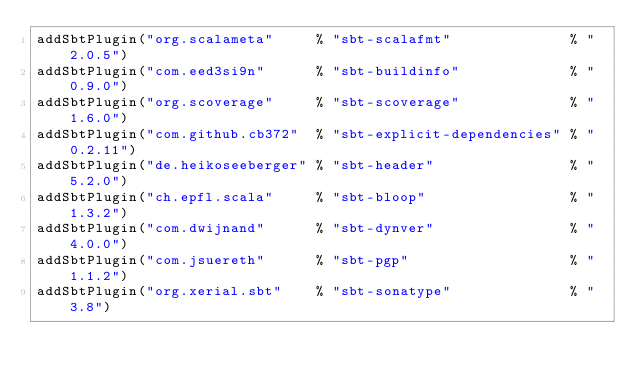Convert code to text. <code><loc_0><loc_0><loc_500><loc_500><_Scala_>addSbtPlugin("org.scalameta"     % "sbt-scalafmt"              % "2.0.5")
addSbtPlugin("com.eed3si9n"      % "sbt-buildinfo"             % "0.9.0")
addSbtPlugin("org.scoverage"     % "sbt-scoverage"             % "1.6.0")
addSbtPlugin("com.github.cb372"  % "sbt-explicit-dependencies" % "0.2.11")
addSbtPlugin("de.heikoseeberger" % "sbt-header"                % "5.2.0")
addSbtPlugin("ch.epfl.scala"     % "sbt-bloop"                 % "1.3.2")
addSbtPlugin("com.dwijnand"      % "sbt-dynver"                % "4.0.0")
addSbtPlugin("com.jsuereth"      % "sbt-pgp"                   % "1.1.2")
addSbtPlugin("org.xerial.sbt"    % "sbt-sonatype"              % "3.8")
</code> 